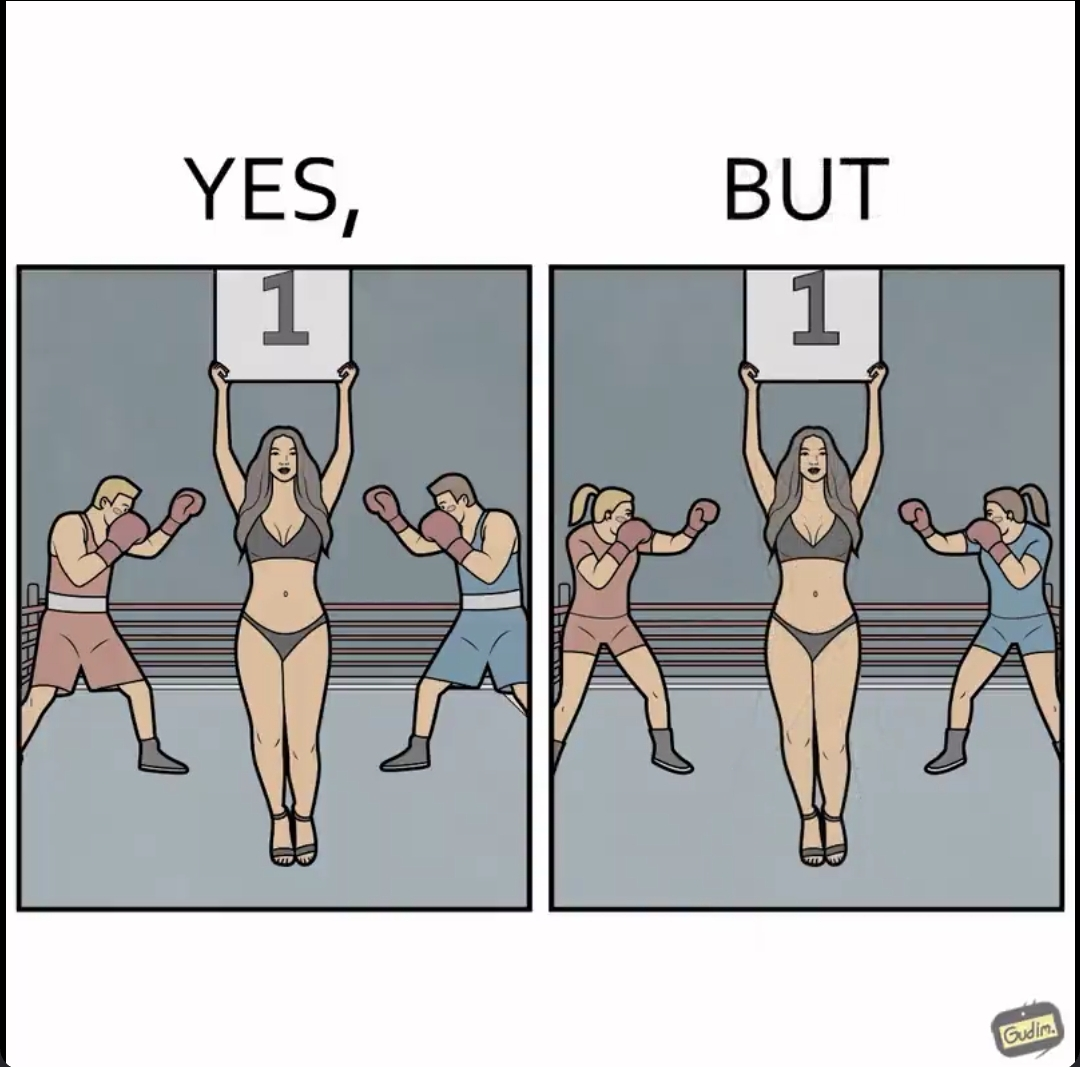Why is this image considered satirical? The images are ironic since it shows how women are represented in our society. When it comes to a men's boxing match, a woman in revealing clothes is expected to hold out boards depicting round numbers but in a women's boxing match, they do not expect men to do so. It is poking fun at the gender roles that exist in our society 